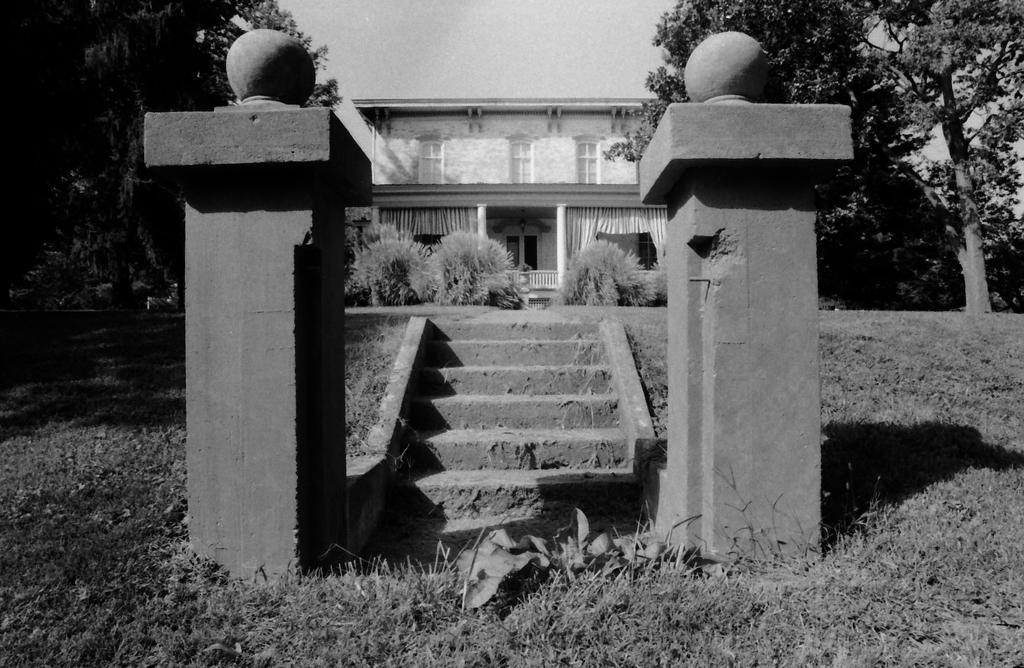Can you describe this image briefly? This is a black and white image. These are the stairs. I think this is a house with the windows. I can see the trees and bushes. This is the grass. I think these are the pillars. 